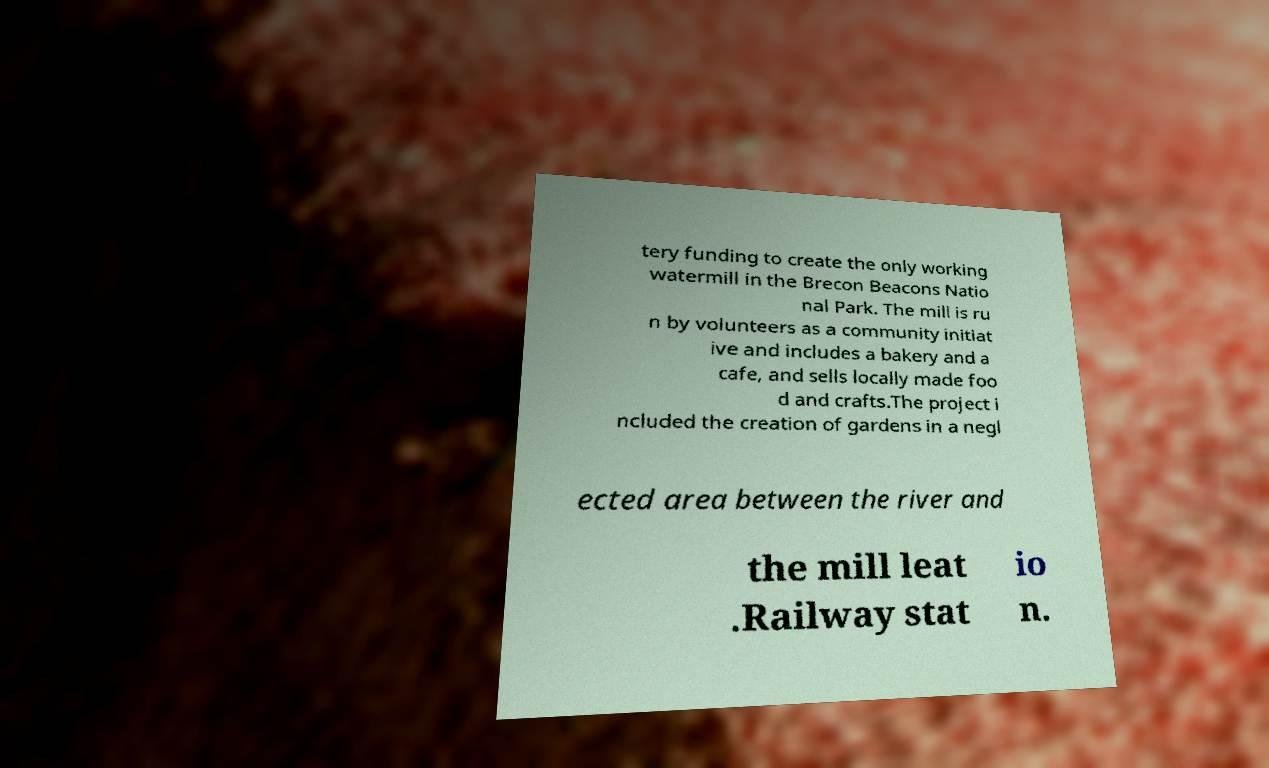Can you read and provide the text displayed in the image?This photo seems to have some interesting text. Can you extract and type it out for me? tery funding to create the only working watermill in the Brecon Beacons Natio nal Park. The mill is ru n by volunteers as a community initiat ive and includes a bakery and a cafe, and sells locally made foo d and crafts.The project i ncluded the creation of gardens in a negl ected area between the river and the mill leat .Railway stat io n. 